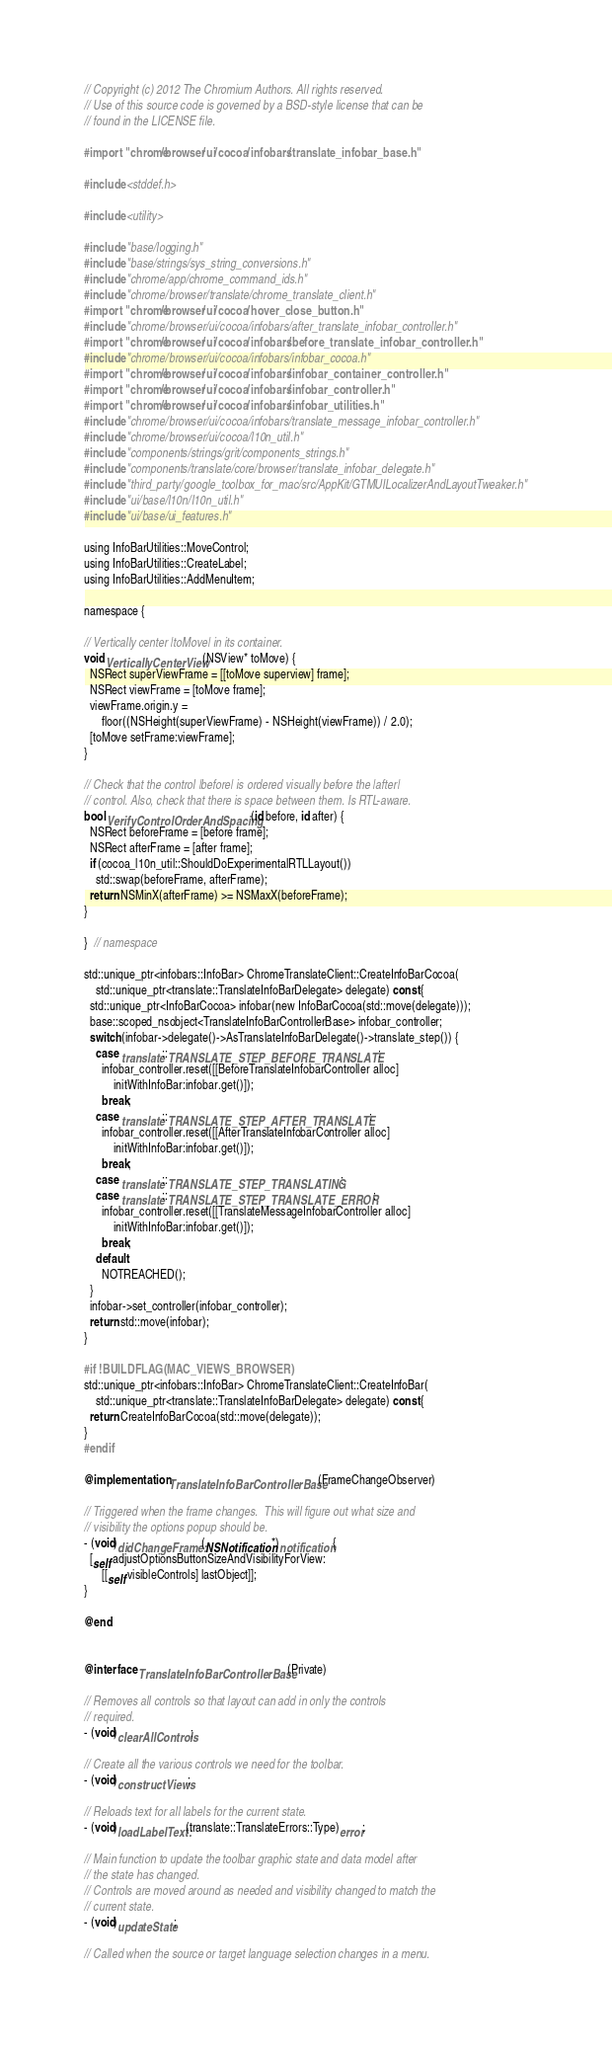Convert code to text. <code><loc_0><loc_0><loc_500><loc_500><_ObjectiveC_>// Copyright (c) 2012 The Chromium Authors. All rights reserved.
// Use of this source code is governed by a BSD-style license that can be
// found in the LICENSE file.

#import "chrome/browser/ui/cocoa/infobars/translate_infobar_base.h"

#include <stddef.h>

#include <utility>

#include "base/logging.h"
#include "base/strings/sys_string_conversions.h"
#include "chrome/app/chrome_command_ids.h"
#include "chrome/browser/translate/chrome_translate_client.h"
#import "chrome/browser/ui/cocoa/hover_close_button.h"
#include "chrome/browser/ui/cocoa/infobars/after_translate_infobar_controller.h"
#import "chrome/browser/ui/cocoa/infobars/before_translate_infobar_controller.h"
#include "chrome/browser/ui/cocoa/infobars/infobar_cocoa.h"
#import "chrome/browser/ui/cocoa/infobars/infobar_container_controller.h"
#import "chrome/browser/ui/cocoa/infobars/infobar_controller.h"
#import "chrome/browser/ui/cocoa/infobars/infobar_utilities.h"
#include "chrome/browser/ui/cocoa/infobars/translate_message_infobar_controller.h"
#include "chrome/browser/ui/cocoa/l10n_util.h"
#include "components/strings/grit/components_strings.h"
#include "components/translate/core/browser/translate_infobar_delegate.h"
#include "third_party/google_toolbox_for_mac/src/AppKit/GTMUILocalizerAndLayoutTweaker.h"
#include "ui/base/l10n/l10n_util.h"
#include "ui/base/ui_features.h"

using InfoBarUtilities::MoveControl;
using InfoBarUtilities::CreateLabel;
using InfoBarUtilities::AddMenuItem;

namespace {

// Vertically center |toMove| in its container.
void VerticallyCenterView(NSView* toMove) {
  NSRect superViewFrame = [[toMove superview] frame];
  NSRect viewFrame = [toMove frame];
  viewFrame.origin.y =
      floor((NSHeight(superViewFrame) - NSHeight(viewFrame)) / 2.0);
  [toMove setFrame:viewFrame];
}

// Check that the control |before| is ordered visually before the |after|
// control. Also, check that there is space between them. Is RTL-aware.
bool VerifyControlOrderAndSpacing(id before, id after) {
  NSRect beforeFrame = [before frame];
  NSRect afterFrame = [after frame];
  if (cocoa_l10n_util::ShouldDoExperimentalRTLLayout())
    std::swap(beforeFrame, afterFrame);
  return NSMinX(afterFrame) >= NSMaxX(beforeFrame);
}

}  // namespace

std::unique_ptr<infobars::InfoBar> ChromeTranslateClient::CreateInfoBarCocoa(
    std::unique_ptr<translate::TranslateInfoBarDelegate> delegate) const {
  std::unique_ptr<InfoBarCocoa> infobar(new InfoBarCocoa(std::move(delegate)));
  base::scoped_nsobject<TranslateInfoBarControllerBase> infobar_controller;
  switch (infobar->delegate()->AsTranslateInfoBarDelegate()->translate_step()) {
    case translate::TRANSLATE_STEP_BEFORE_TRANSLATE:
      infobar_controller.reset([[BeforeTranslateInfobarController alloc]
          initWithInfoBar:infobar.get()]);
      break;
    case translate::TRANSLATE_STEP_AFTER_TRANSLATE:
      infobar_controller.reset([[AfterTranslateInfobarController alloc]
          initWithInfoBar:infobar.get()]);
      break;
    case translate::TRANSLATE_STEP_TRANSLATING:
    case translate::TRANSLATE_STEP_TRANSLATE_ERROR:
      infobar_controller.reset([[TranslateMessageInfobarController alloc]
          initWithInfoBar:infobar.get()]);
      break;
    default:
      NOTREACHED();
  }
  infobar->set_controller(infobar_controller);
  return std::move(infobar);
}

#if !BUILDFLAG(MAC_VIEWS_BROWSER)
std::unique_ptr<infobars::InfoBar> ChromeTranslateClient::CreateInfoBar(
    std::unique_ptr<translate::TranslateInfoBarDelegate> delegate) const {
  return CreateInfoBarCocoa(std::move(delegate));
}
#endif

@implementation TranslateInfoBarControllerBase (FrameChangeObserver)

// Triggered when the frame changes.  This will figure out what size and
// visibility the options popup should be.
- (void)didChangeFrame:(NSNotification*)notification {
  [self adjustOptionsButtonSizeAndVisibilityForView:
      [[self visibleControls] lastObject]];
}

@end


@interface TranslateInfoBarControllerBase (Private)

// Removes all controls so that layout can add in only the controls
// required.
- (void)clearAllControls;

// Create all the various controls we need for the toolbar.
- (void)constructViews;

// Reloads text for all labels for the current state.
- (void)loadLabelText:(translate::TranslateErrors::Type)error;

// Main function to update the toolbar graphic state and data model after
// the state has changed.
// Controls are moved around as needed and visibility changed to match the
// current state.
- (void)updateState;

// Called when the source or target language selection changes in a menu.</code> 